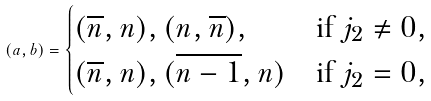Convert formula to latex. <formula><loc_0><loc_0><loc_500><loc_500>( a , b ) = \begin{cases} ( \overline { n } , n ) , ( n , \overline { n } ) , & \text {if $j_{2} \ne 0$} , \\ ( \overline { n } , n ) , ( \overline { n - 1 } , n ) & \text {if $j_{2}=0$} , \\ \end{cases}</formula> 